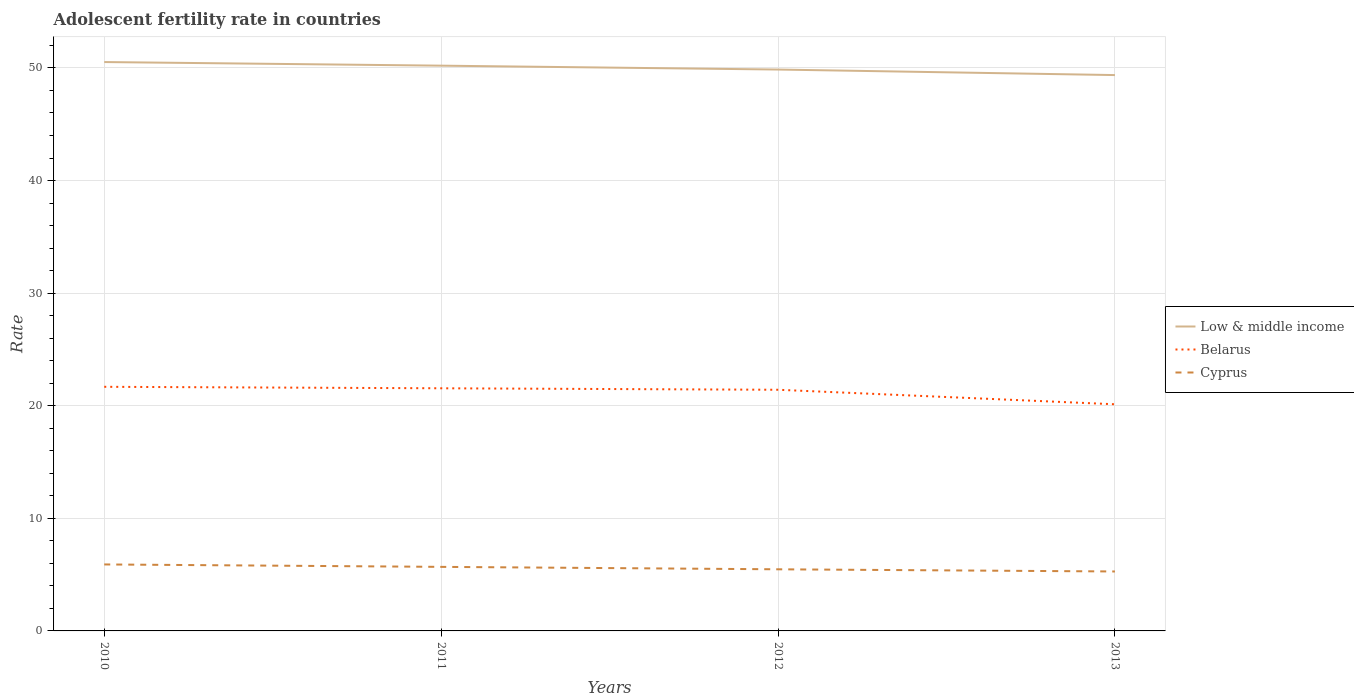How many different coloured lines are there?
Provide a succinct answer. 3. Does the line corresponding to Low & middle income intersect with the line corresponding to Belarus?
Offer a very short reply. No. Across all years, what is the maximum adolescent fertility rate in Cyprus?
Keep it short and to the point. 5.28. In which year was the adolescent fertility rate in Cyprus maximum?
Your response must be concise. 2013. What is the total adolescent fertility rate in Low & middle income in the graph?
Make the answer very short. 0.35. What is the difference between the highest and the second highest adolescent fertility rate in Belarus?
Your answer should be compact. 1.55. Is the adolescent fertility rate in Low & middle income strictly greater than the adolescent fertility rate in Belarus over the years?
Your response must be concise. No. How many lines are there?
Offer a terse response. 3. How many years are there in the graph?
Make the answer very short. 4. What is the difference between two consecutive major ticks on the Y-axis?
Provide a short and direct response. 10. Are the values on the major ticks of Y-axis written in scientific E-notation?
Offer a terse response. No. Where does the legend appear in the graph?
Ensure brevity in your answer.  Center right. What is the title of the graph?
Offer a terse response. Adolescent fertility rate in countries. What is the label or title of the Y-axis?
Offer a terse response. Rate. What is the Rate in Low & middle income in 2010?
Your answer should be very brief. 50.52. What is the Rate of Belarus in 2010?
Keep it short and to the point. 21.68. What is the Rate of Cyprus in 2010?
Your response must be concise. 5.9. What is the Rate of Low & middle income in 2011?
Ensure brevity in your answer.  50.2. What is the Rate of Belarus in 2011?
Provide a succinct answer. 21.55. What is the Rate of Cyprus in 2011?
Provide a succinct answer. 5.69. What is the Rate in Low & middle income in 2012?
Offer a very short reply. 49.86. What is the Rate in Belarus in 2012?
Offer a very short reply. 21.42. What is the Rate of Cyprus in 2012?
Make the answer very short. 5.47. What is the Rate in Low & middle income in 2013?
Offer a very short reply. 49.37. What is the Rate in Belarus in 2013?
Provide a succinct answer. 20.13. What is the Rate of Cyprus in 2013?
Your answer should be compact. 5.28. Across all years, what is the maximum Rate in Low & middle income?
Your response must be concise. 50.52. Across all years, what is the maximum Rate in Belarus?
Give a very brief answer. 21.68. Across all years, what is the maximum Rate in Cyprus?
Keep it short and to the point. 5.9. Across all years, what is the minimum Rate in Low & middle income?
Offer a terse response. 49.37. Across all years, what is the minimum Rate in Belarus?
Keep it short and to the point. 20.13. Across all years, what is the minimum Rate in Cyprus?
Ensure brevity in your answer.  5.28. What is the total Rate in Low & middle income in the graph?
Offer a very short reply. 199.95. What is the total Rate of Belarus in the graph?
Ensure brevity in your answer.  84.78. What is the total Rate of Cyprus in the graph?
Offer a terse response. 22.35. What is the difference between the Rate in Low & middle income in 2010 and that in 2011?
Ensure brevity in your answer.  0.32. What is the difference between the Rate of Belarus in 2010 and that in 2011?
Provide a short and direct response. 0.13. What is the difference between the Rate of Cyprus in 2010 and that in 2011?
Your response must be concise. 0.22. What is the difference between the Rate of Low & middle income in 2010 and that in 2012?
Your answer should be very brief. 0.67. What is the difference between the Rate of Belarus in 2010 and that in 2012?
Provide a succinct answer. 0.26. What is the difference between the Rate of Cyprus in 2010 and that in 2012?
Your answer should be compact. 0.43. What is the difference between the Rate in Low & middle income in 2010 and that in 2013?
Keep it short and to the point. 1.16. What is the difference between the Rate in Belarus in 2010 and that in 2013?
Offer a very short reply. 1.55. What is the difference between the Rate of Cyprus in 2010 and that in 2013?
Your answer should be very brief. 0.63. What is the difference between the Rate in Low & middle income in 2011 and that in 2012?
Provide a succinct answer. 0.34. What is the difference between the Rate in Belarus in 2011 and that in 2012?
Ensure brevity in your answer.  0.13. What is the difference between the Rate of Cyprus in 2011 and that in 2012?
Give a very brief answer. 0.22. What is the difference between the Rate in Low & middle income in 2011 and that in 2013?
Ensure brevity in your answer.  0.84. What is the difference between the Rate of Belarus in 2011 and that in 2013?
Your response must be concise. 1.42. What is the difference between the Rate of Cyprus in 2011 and that in 2013?
Provide a short and direct response. 0.41. What is the difference between the Rate in Low & middle income in 2012 and that in 2013?
Offer a very short reply. 0.49. What is the difference between the Rate in Belarus in 2012 and that in 2013?
Offer a very short reply. 1.29. What is the difference between the Rate of Cyprus in 2012 and that in 2013?
Ensure brevity in your answer.  0.19. What is the difference between the Rate in Low & middle income in 2010 and the Rate in Belarus in 2011?
Make the answer very short. 28.97. What is the difference between the Rate in Low & middle income in 2010 and the Rate in Cyprus in 2011?
Offer a very short reply. 44.83. What is the difference between the Rate in Belarus in 2010 and the Rate in Cyprus in 2011?
Provide a succinct answer. 15.99. What is the difference between the Rate of Low & middle income in 2010 and the Rate of Belarus in 2012?
Keep it short and to the point. 29.11. What is the difference between the Rate in Low & middle income in 2010 and the Rate in Cyprus in 2012?
Give a very brief answer. 45.05. What is the difference between the Rate of Belarus in 2010 and the Rate of Cyprus in 2012?
Offer a very short reply. 16.21. What is the difference between the Rate of Low & middle income in 2010 and the Rate of Belarus in 2013?
Provide a short and direct response. 30.39. What is the difference between the Rate of Low & middle income in 2010 and the Rate of Cyprus in 2013?
Offer a very short reply. 45.24. What is the difference between the Rate of Belarus in 2010 and the Rate of Cyprus in 2013?
Provide a succinct answer. 16.4. What is the difference between the Rate of Low & middle income in 2011 and the Rate of Belarus in 2012?
Ensure brevity in your answer.  28.79. What is the difference between the Rate of Low & middle income in 2011 and the Rate of Cyprus in 2012?
Your answer should be very brief. 44.73. What is the difference between the Rate of Belarus in 2011 and the Rate of Cyprus in 2012?
Provide a short and direct response. 16.08. What is the difference between the Rate of Low & middle income in 2011 and the Rate of Belarus in 2013?
Offer a terse response. 30.07. What is the difference between the Rate in Low & middle income in 2011 and the Rate in Cyprus in 2013?
Offer a very short reply. 44.92. What is the difference between the Rate in Belarus in 2011 and the Rate in Cyprus in 2013?
Your answer should be very brief. 16.27. What is the difference between the Rate in Low & middle income in 2012 and the Rate in Belarus in 2013?
Offer a very short reply. 29.73. What is the difference between the Rate in Low & middle income in 2012 and the Rate in Cyprus in 2013?
Provide a short and direct response. 44.58. What is the difference between the Rate in Belarus in 2012 and the Rate in Cyprus in 2013?
Provide a succinct answer. 16.14. What is the average Rate in Low & middle income per year?
Give a very brief answer. 49.99. What is the average Rate of Belarus per year?
Give a very brief answer. 21.19. What is the average Rate of Cyprus per year?
Keep it short and to the point. 5.59. In the year 2010, what is the difference between the Rate of Low & middle income and Rate of Belarus?
Ensure brevity in your answer.  28.84. In the year 2010, what is the difference between the Rate of Low & middle income and Rate of Cyprus?
Keep it short and to the point. 44.62. In the year 2010, what is the difference between the Rate in Belarus and Rate in Cyprus?
Offer a terse response. 15.78. In the year 2011, what is the difference between the Rate of Low & middle income and Rate of Belarus?
Your answer should be compact. 28.65. In the year 2011, what is the difference between the Rate in Low & middle income and Rate in Cyprus?
Ensure brevity in your answer.  44.51. In the year 2011, what is the difference between the Rate in Belarus and Rate in Cyprus?
Give a very brief answer. 15.86. In the year 2012, what is the difference between the Rate of Low & middle income and Rate of Belarus?
Your response must be concise. 28.44. In the year 2012, what is the difference between the Rate in Low & middle income and Rate in Cyprus?
Your response must be concise. 44.38. In the year 2012, what is the difference between the Rate in Belarus and Rate in Cyprus?
Offer a terse response. 15.95. In the year 2013, what is the difference between the Rate of Low & middle income and Rate of Belarus?
Provide a short and direct response. 29.24. In the year 2013, what is the difference between the Rate of Low & middle income and Rate of Cyprus?
Keep it short and to the point. 44.09. In the year 2013, what is the difference between the Rate of Belarus and Rate of Cyprus?
Your response must be concise. 14.85. What is the ratio of the Rate in Low & middle income in 2010 to that in 2011?
Provide a short and direct response. 1.01. What is the ratio of the Rate of Belarus in 2010 to that in 2011?
Offer a very short reply. 1.01. What is the ratio of the Rate of Cyprus in 2010 to that in 2011?
Offer a very short reply. 1.04. What is the ratio of the Rate of Low & middle income in 2010 to that in 2012?
Make the answer very short. 1.01. What is the ratio of the Rate in Belarus in 2010 to that in 2012?
Give a very brief answer. 1.01. What is the ratio of the Rate in Cyprus in 2010 to that in 2012?
Ensure brevity in your answer.  1.08. What is the ratio of the Rate in Low & middle income in 2010 to that in 2013?
Offer a very short reply. 1.02. What is the ratio of the Rate of Belarus in 2010 to that in 2013?
Your response must be concise. 1.08. What is the ratio of the Rate in Cyprus in 2010 to that in 2013?
Your response must be concise. 1.12. What is the ratio of the Rate in Cyprus in 2011 to that in 2012?
Provide a short and direct response. 1.04. What is the ratio of the Rate of Low & middle income in 2011 to that in 2013?
Make the answer very short. 1.02. What is the ratio of the Rate in Belarus in 2011 to that in 2013?
Offer a terse response. 1.07. What is the ratio of the Rate in Cyprus in 2011 to that in 2013?
Offer a very short reply. 1.08. What is the ratio of the Rate of Low & middle income in 2012 to that in 2013?
Your response must be concise. 1.01. What is the ratio of the Rate of Belarus in 2012 to that in 2013?
Provide a succinct answer. 1.06. What is the ratio of the Rate in Cyprus in 2012 to that in 2013?
Provide a succinct answer. 1.04. What is the difference between the highest and the second highest Rate of Low & middle income?
Provide a short and direct response. 0.32. What is the difference between the highest and the second highest Rate in Belarus?
Your answer should be very brief. 0.13. What is the difference between the highest and the second highest Rate of Cyprus?
Give a very brief answer. 0.22. What is the difference between the highest and the lowest Rate in Low & middle income?
Provide a succinct answer. 1.16. What is the difference between the highest and the lowest Rate in Belarus?
Provide a short and direct response. 1.55. What is the difference between the highest and the lowest Rate in Cyprus?
Ensure brevity in your answer.  0.63. 